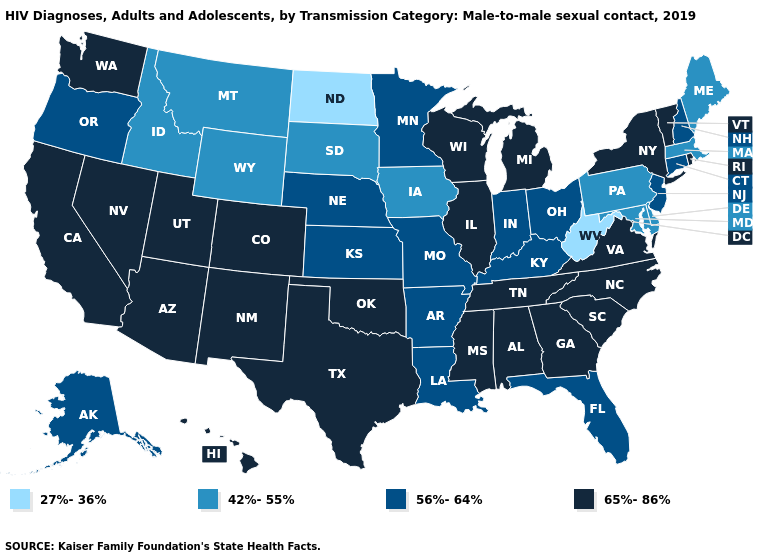Does Maine have the lowest value in the Northeast?
Keep it brief. Yes. Name the states that have a value in the range 65%-86%?
Short answer required. Alabama, Arizona, California, Colorado, Georgia, Hawaii, Illinois, Michigan, Mississippi, Nevada, New Mexico, New York, North Carolina, Oklahoma, Rhode Island, South Carolina, Tennessee, Texas, Utah, Vermont, Virginia, Washington, Wisconsin. Name the states that have a value in the range 42%-55%?
Answer briefly. Delaware, Idaho, Iowa, Maine, Maryland, Massachusetts, Montana, Pennsylvania, South Dakota, Wyoming. What is the value of Colorado?
Keep it brief. 65%-86%. Does North Dakota have the lowest value in the USA?
Answer briefly. Yes. Which states hav the highest value in the South?
Answer briefly. Alabama, Georgia, Mississippi, North Carolina, Oklahoma, South Carolina, Tennessee, Texas, Virginia. Name the states that have a value in the range 42%-55%?
Keep it brief. Delaware, Idaho, Iowa, Maine, Maryland, Massachusetts, Montana, Pennsylvania, South Dakota, Wyoming. What is the value of Oklahoma?
Short answer required. 65%-86%. What is the value of Arkansas?
Keep it brief. 56%-64%. What is the highest value in states that border North Dakota?
Keep it brief. 56%-64%. What is the value of Ohio?
Answer briefly. 56%-64%. Among the states that border Iowa , does South Dakota have the lowest value?
Quick response, please. Yes. Does New Hampshire have a lower value than Nevada?
Concise answer only. Yes. Name the states that have a value in the range 65%-86%?
Short answer required. Alabama, Arizona, California, Colorado, Georgia, Hawaii, Illinois, Michigan, Mississippi, Nevada, New Mexico, New York, North Carolina, Oklahoma, Rhode Island, South Carolina, Tennessee, Texas, Utah, Vermont, Virginia, Washington, Wisconsin. What is the lowest value in states that border Kansas?
Concise answer only. 56%-64%. 